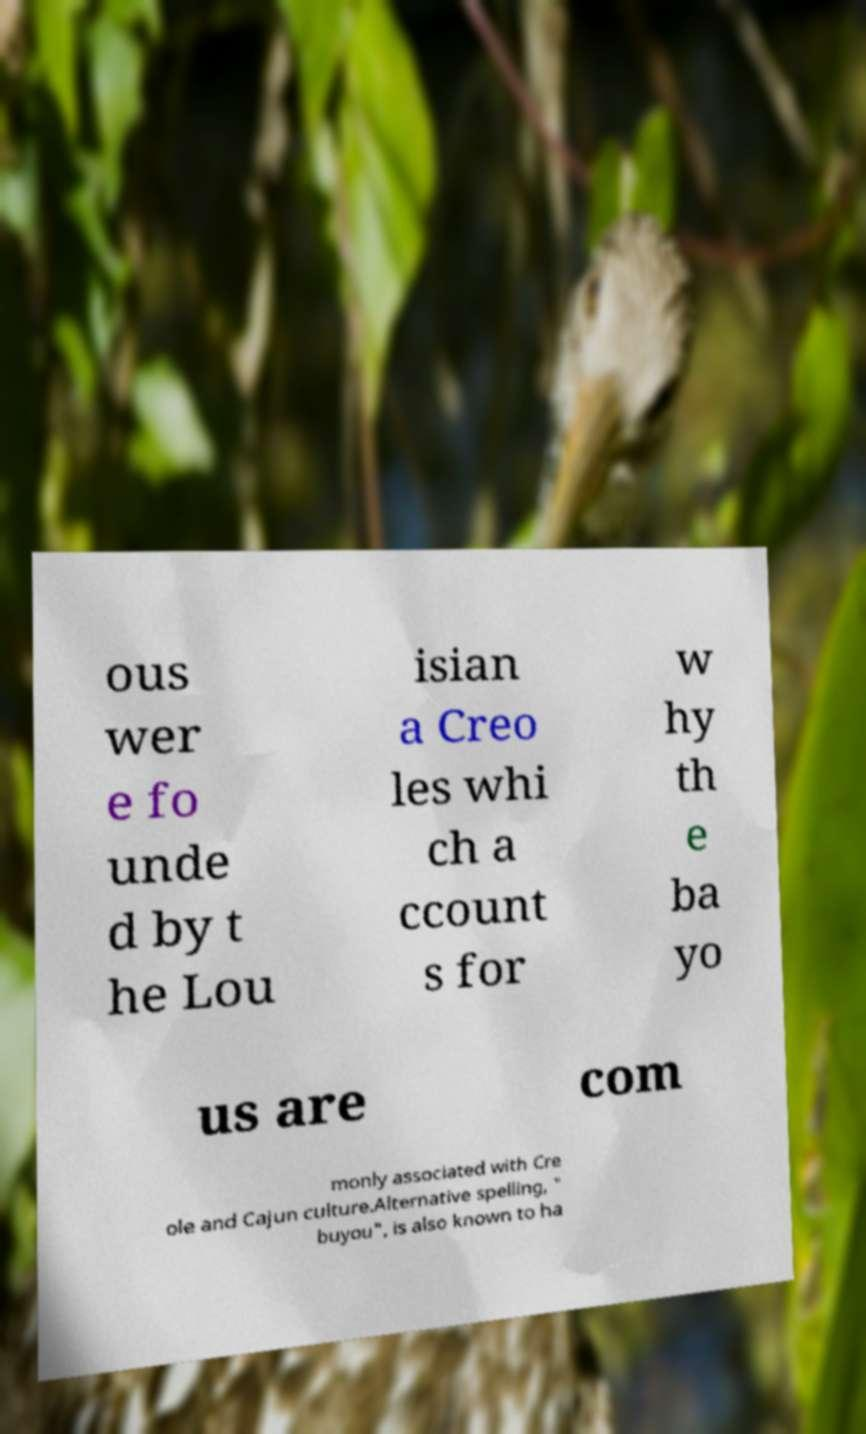There's text embedded in this image that I need extracted. Can you transcribe it verbatim? ous wer e fo unde d by t he Lou isian a Creo les whi ch a ccount s for w hy th e ba yo us are com monly associated with Cre ole and Cajun culture.Alternative spelling, " buyou", is also known to ha 